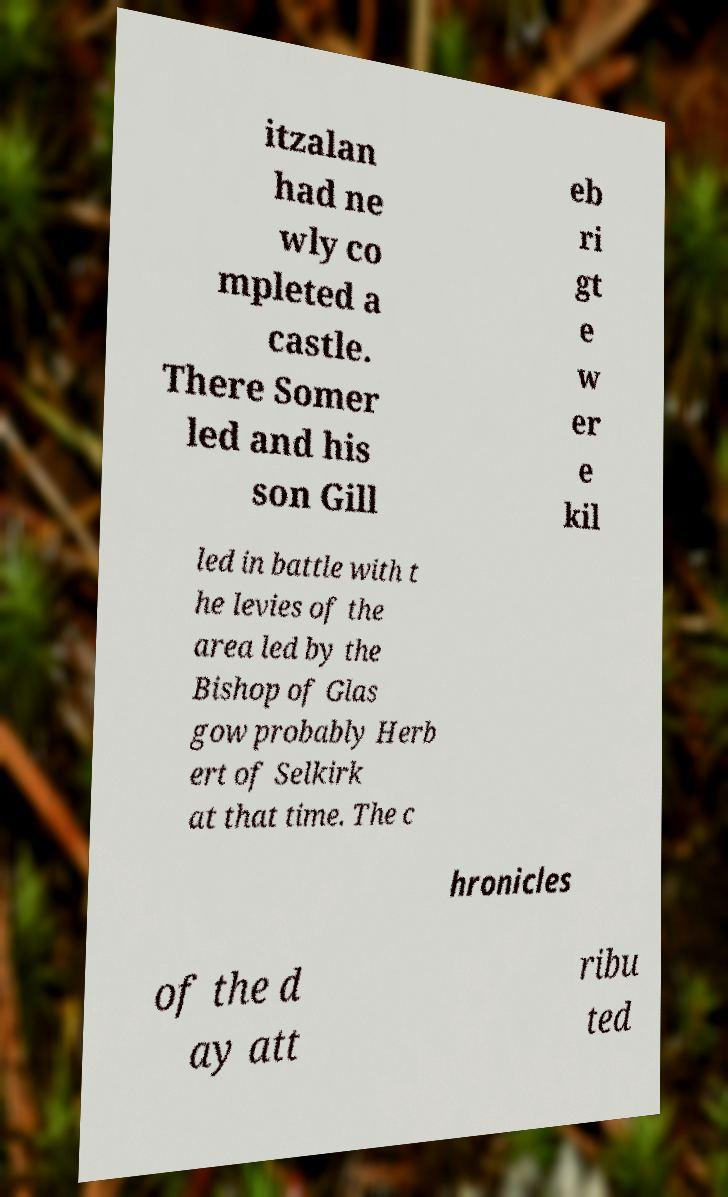Could you extract and type out the text from this image? itzalan had ne wly co mpleted a castle. There Somer led and his son Gill eb ri gt e w er e kil led in battle with t he levies of the area led by the Bishop of Glas gow probably Herb ert of Selkirk at that time. The c hronicles of the d ay att ribu ted 